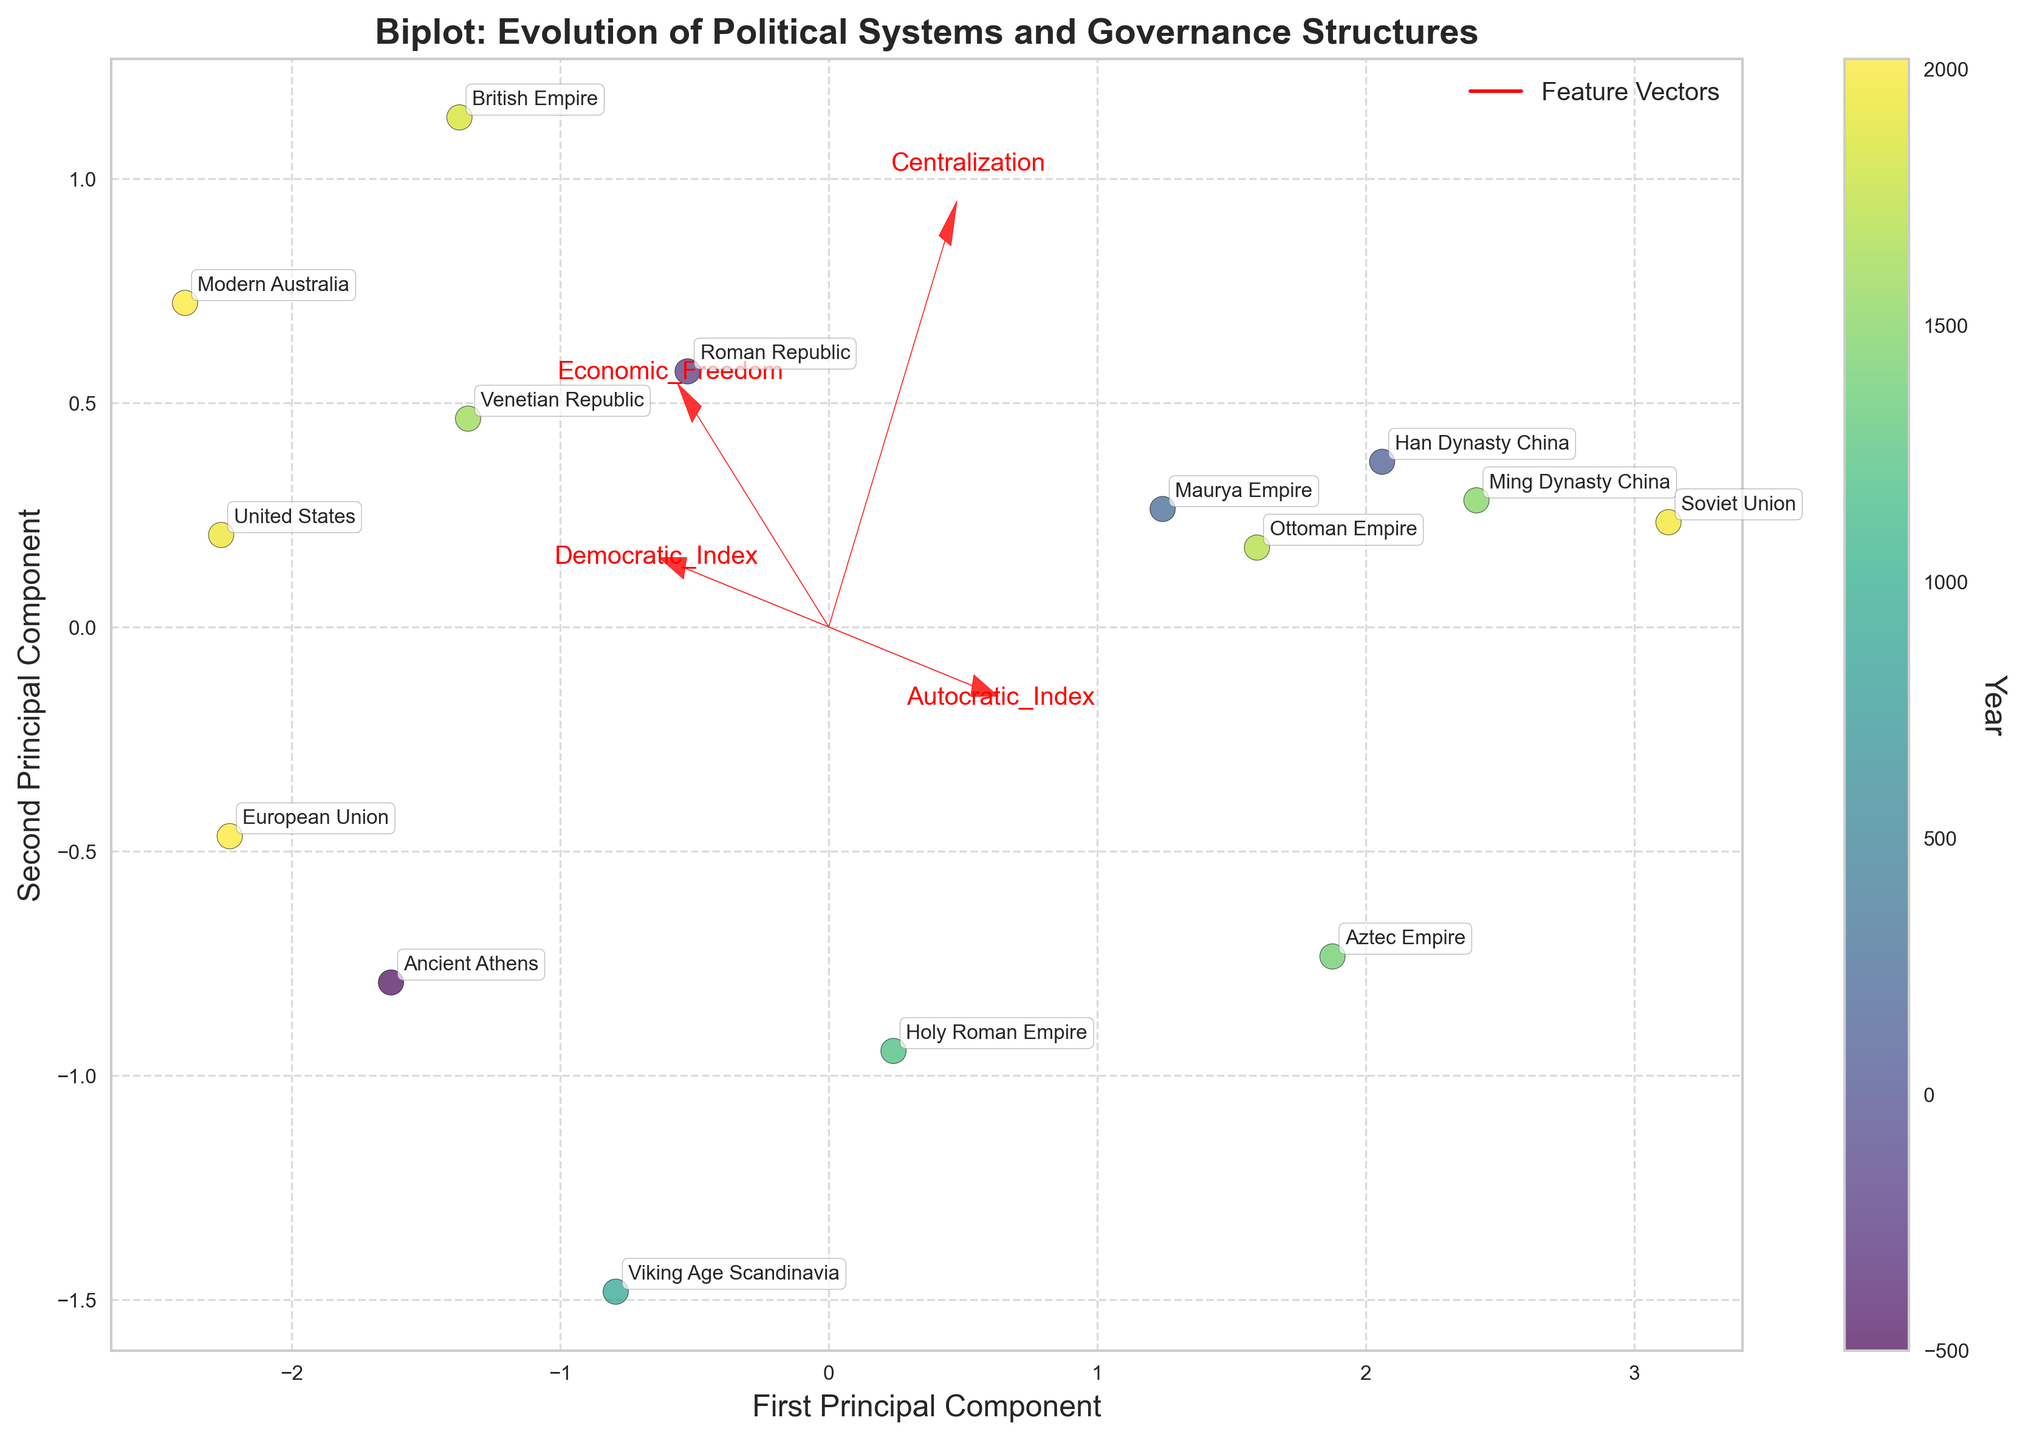What is the title of the figure? The title is always located at the top of the figure, usually in a larger font size or bold style.
Answer: Biplot: Evolution of Political Systems and Governance Structures How many data points are displayed in the figure? Data points are represented by the scatter plot markers in the biplot. By counting the number of these markers, we can determine the number of data points.
Answer: 15 What region corresponds to the data point located closest to the origin (0,0)? To find the region closest to the origin, look at the scatter plot points and identify which one is near the coordinates (0,0).
Answer: Holy Roman Empire Which data point corresponds to the region with the highest level of Economic Freedom? Economic Freedom is represented by a feature vector. The direction with the longest vector length for Economic Freedom indicates the regions. Find the data point closest to this direction.
Answer: British Empire What does the color gradient on the data points represent? The color gradient is explained by the colorbar located beside the figure. It usually signifies a certain attribute, which in this case, seems to be indicated by the year of the data point.
Answer: Year Which regions are most similar based on their principal components? Regions close to each other on the biplot have similar principal component scores. Identify the clusters by their proximity.
Answer: Modern Australia and European Union Which feature vector points in the same general direction as the first principal component? The first principal component is along the x-axis. The feature vector pointing in nearly the same horizontal direction as this axis is what we need to identify.
Answer: Economic Freedom How does the democratic index of Ancient Athens compare to Soviet Union based on their positions in the biplot? To compare the democratic indexes, observe their positions along the vector representing the Democratic Index. The position further along this vector correlates with a higher index.
Answer: Higher Which feature vectors are oriented opposite to each other? Feature vectors pointing in almost exactly opposite directions in the plot can be considered opposites.
Answer: Democratic_Index and Autocratic_Index What can you infer about the centralization level of Ming Dynasty China? The feature vector for Centralization helps gauge the centralization level. The data points located further along this vector have higher centralization.
Answer: Very high 